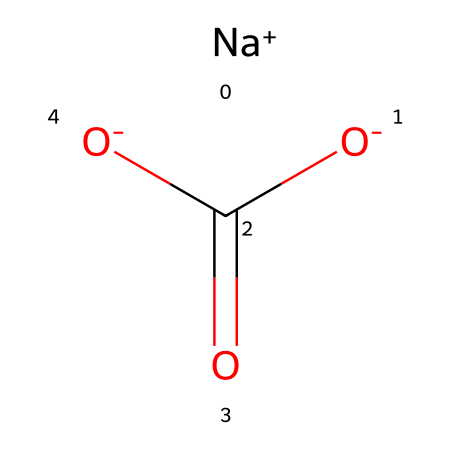How many carbon atoms are in the structure? The chemical structure shows one carbon atom in the central part of the formula (C(=O)). This is indicated by the presence of the letter "C" in the SMILES notation.
Answer: one What type of bond exists between carbon and the oxygen in the carboxylate group? The structure includes a carbon atom double bonded to one oxygen atom (C=O) and single bonded to another oxygen atom (COO). The double bond is indicated by the "=" sign in the SMILES representation.
Answer: double bond How many oxygen atoms are present in this compound? The chemical structure has three oxygen atoms: one in the carbonyl (C=O) and two in the carboxylate group (O-COO). Counting them in the SMILES notation reveals three total.
Answer: three What kind of compound is sodium bicarbonate classified as? Sodium bicarbonate, represented by this structure, can be classified as an electrolyte, which is a substance that dissociates into ions when dissolved in water, allowing for electrical conductivity. The presence of sodium ions (Na+) supports this classification.
Answer: electrolyte What is the overall charge of sodium bicarbonate? In the given structure, sodium (Na+) carries a positive charge while the bicarbonate part (HCO3-) carries a negative charge. Overall, the charges balance each other to give the compound a net neutral charge.
Answer: neutral Which ions does sodium bicarbonate dissociate into in solution? When dissolved in water, sodium bicarbonate dissociates into sodium ions (Na+) and bicarbonate ions (HCO3-). The dissociation can be inferred from the structure since the sodium ion is explicitly shown alongside the bicarbonate part.
Answer: sodium and bicarbonate ions Does this compound act as an acid or a base? Sodium bicarbonate acts as a weak base in aqueous solution. The presence of the bicarbonate ion allows it to accept protons (H+), making it capable of neutralizing acids. This behavior can be deduced from its structure showing the bicarbonate moiety.
Answer: weak base 